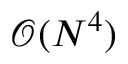<formula> <loc_0><loc_0><loc_500><loc_500>\mathcal { O } ( N ^ { 4 } )</formula> 